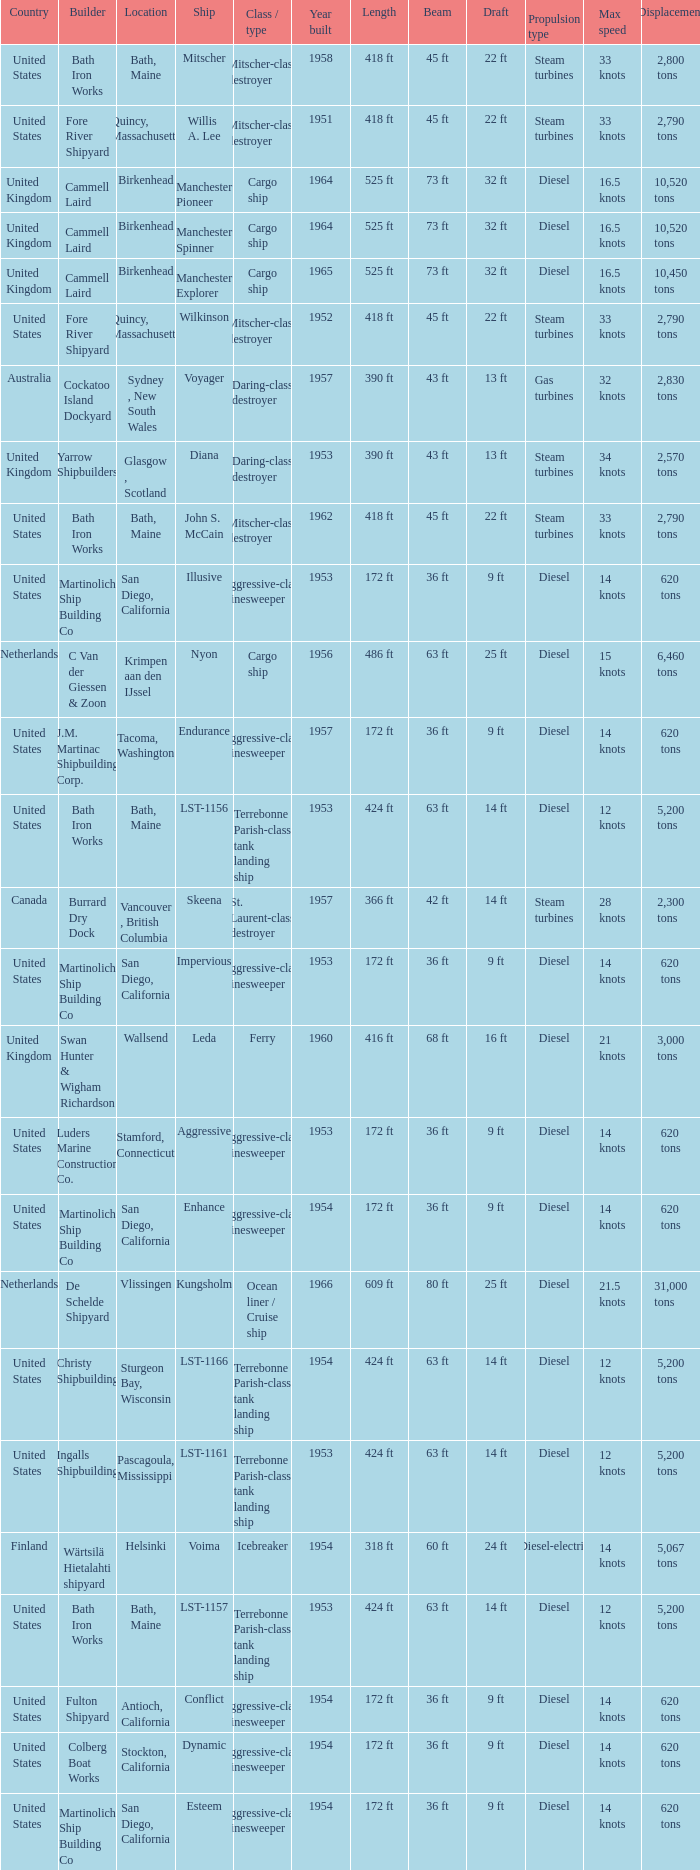Could you parse the entire table? {'header': ['Country', 'Builder', 'Location', 'Ship', 'Class / type', 'Year built', 'Length', 'Beam', 'Draft', 'Propulsion type', 'Max speed', 'Displacement'], 'rows': [['United States', 'Bath Iron Works', 'Bath, Maine', 'Mitscher', 'Mitscher-class destroyer', '1958', '418 ft', '45 ft', '22 ft', 'Steam turbines', '33 knots', '2,800 tons'], ['United States', 'Fore River Shipyard', 'Quincy, Massachusetts', 'Willis A. Lee', 'Mitscher-class destroyer', '1951', '418 ft', '45 ft', '22 ft', 'Steam turbines', '33 knots', '2,790 tons'], ['United Kingdom', 'Cammell Laird', 'Birkenhead', 'Manchester Pioneer', 'Cargo ship', '1964', '525 ft', '73 ft', '32 ft', 'Diesel', '16.5 knots', '10,520 tons'], ['United Kingdom', 'Cammell Laird', 'Birkenhead', 'Manchester Spinner', 'Cargo ship', '1964', '525 ft', '73 ft', '32 ft', 'Diesel', '16.5 knots', '10,520 tons'], ['United Kingdom', 'Cammell Laird', 'Birkenhead', 'Manchester Explorer', 'Cargo ship', '1965', '525 ft', '73 ft', '32 ft', 'Diesel', '16.5 knots', '10,450 tons'], ['United States', 'Fore River Shipyard', 'Quincy, Massachusetts', 'Wilkinson', 'Mitscher-class destroyer', '1952', '418 ft', '45 ft', '22 ft', 'Steam turbines', '33 knots', '2,790 tons'], ['Australia', 'Cockatoo Island Dockyard', 'Sydney , New South Wales', 'Voyager', 'Daring-class destroyer', '1957', '390 ft', '43 ft', '13 ft', 'Gas turbines', '32 knots', '2,830 tons'], ['United Kingdom', 'Yarrow Shipbuilders', 'Glasgow , Scotland', 'Diana', 'Daring-class destroyer', '1953', '390 ft', '43 ft', '13 ft', 'Steam turbines', '34 knots', '2,570 tons'], ['United States', 'Bath Iron Works', 'Bath, Maine', 'John S. McCain', 'Mitscher-class destroyer', '1962', '418 ft', '45 ft', '22 ft', 'Steam turbines', '33 knots', '2,790 tons'], ['United States', 'Martinolich Ship Building Co', 'San Diego, California', 'Illusive', 'Aggressive-class minesweeper', '1953', '172 ft', '36 ft', '9 ft', 'Diesel', '14 knots', '620 tons'], ['Netherlands', 'C Van der Giessen & Zoon', 'Krimpen aan den IJssel', 'Nyon', 'Cargo ship', '1956', '486 ft', '63 ft', '25 ft', 'Diesel', '15 knots', '6,460 tons'], ['United States', 'J.M. Martinac Shipbuilding Corp.', 'Tacoma, Washington', 'Endurance', 'Aggressive-class minesweeper', '1957', '172 ft', '36 ft', '9 ft', 'Diesel', '14 knots', '620 tons'], ['United States', 'Bath Iron Works', 'Bath, Maine', 'LST-1156', 'Terrebonne Parish-class tank landing ship', '1953', '424 ft', '63 ft', '14 ft', 'Diesel', '12 knots', '5,200 tons'], ['Canada', 'Burrard Dry Dock', 'Vancouver , British Columbia', 'Skeena', 'St. Laurent-class destroyer', '1957', '366 ft', '42 ft', '14 ft', 'Steam turbines', '28 knots', '2,300 tons'], ['United States', 'Martinolich Ship Building Co', 'San Diego, California', 'Impervious', 'Aggressive-class minesweeper', '1953', '172 ft', '36 ft', '9 ft', 'Diesel', '14 knots', '620 tons'], ['United Kingdom', 'Swan Hunter & Wigham Richardson', 'Wallsend', 'Leda', 'Ferry', '1960', '416 ft', '68 ft', '16 ft', 'Diesel', '21 knots', '3,000 tons'], ['United States', 'Luders Marine Construction Co.', 'Stamford, Connecticut', 'Aggressive', 'Aggressive-class minesweeper', '1953', '172 ft', '36 ft', '9 ft', 'Diesel', '14 knots', '620 tons'], ['United States', 'Martinolich Ship Building Co', 'San Diego, California', 'Enhance', 'Aggressive-class minesweeper', '1954', '172 ft', '36 ft', '9 ft', 'Diesel', '14 knots', '620 tons'], ['Netherlands', 'De Schelde Shipyard', 'Vlissingen', 'Kungsholm', 'Ocean liner / Cruise ship', '1966', '609 ft', '80 ft', '25 ft', 'Diesel', '21.5 knots', '31,000 tons'], ['United States', 'Christy Shipbuilding', 'Sturgeon Bay, Wisconsin', 'LST-1166', 'Terrebonne Parish-class tank landing ship', '1954', '424 ft', '63 ft', '14 ft', 'Diesel', '12 knots', '5,200 tons'], ['United States', 'Ingalls Shipbuilding', 'Pascagoula, Mississippi', 'LST-1161', 'Terrebonne Parish-class tank landing ship', '1953', '424 ft', '63 ft', '14 ft', 'Diesel', '12 knots', '5,200 tons'], ['Finland', 'Wärtsilä Hietalahti shipyard', 'Helsinki', 'Voima', 'Icebreaker', '1954', '318 ft', '60 ft', '24 ft', 'Diesel-electric', '14 knots', '5,067 tons'], ['United States', 'Bath Iron Works', 'Bath, Maine', 'LST-1157', 'Terrebonne Parish-class tank landing ship', '1953', '424 ft', '63 ft', '14 ft', 'Diesel', '12 knots', '5,200 tons'], ['United States', 'Fulton Shipyard', 'Antioch, California', 'Conflict', 'Aggressive-class minesweeper', '1954', '172 ft', '36 ft', '9 ft', 'Diesel', '14 knots', '620 tons'], ['United States', 'Colberg Boat Works', 'Stockton, California', 'Dynamic', 'Aggressive-class minesweeper', '1954', '172 ft', '36 ft', '9 ft', 'Diesel', '14 knots', '620 tons'], ['United States', 'Martinolich Ship Building Co', 'San Diego, California', 'Esteem', 'Aggressive-class minesweeper', '1954', '172 ft', '36 ft', '9 ft', 'Diesel', '14 knots', '620 tons']]} What is the Cargo Ship located at Birkenhead? Manchester Pioneer, Manchester Spinner, Manchester Explorer. 